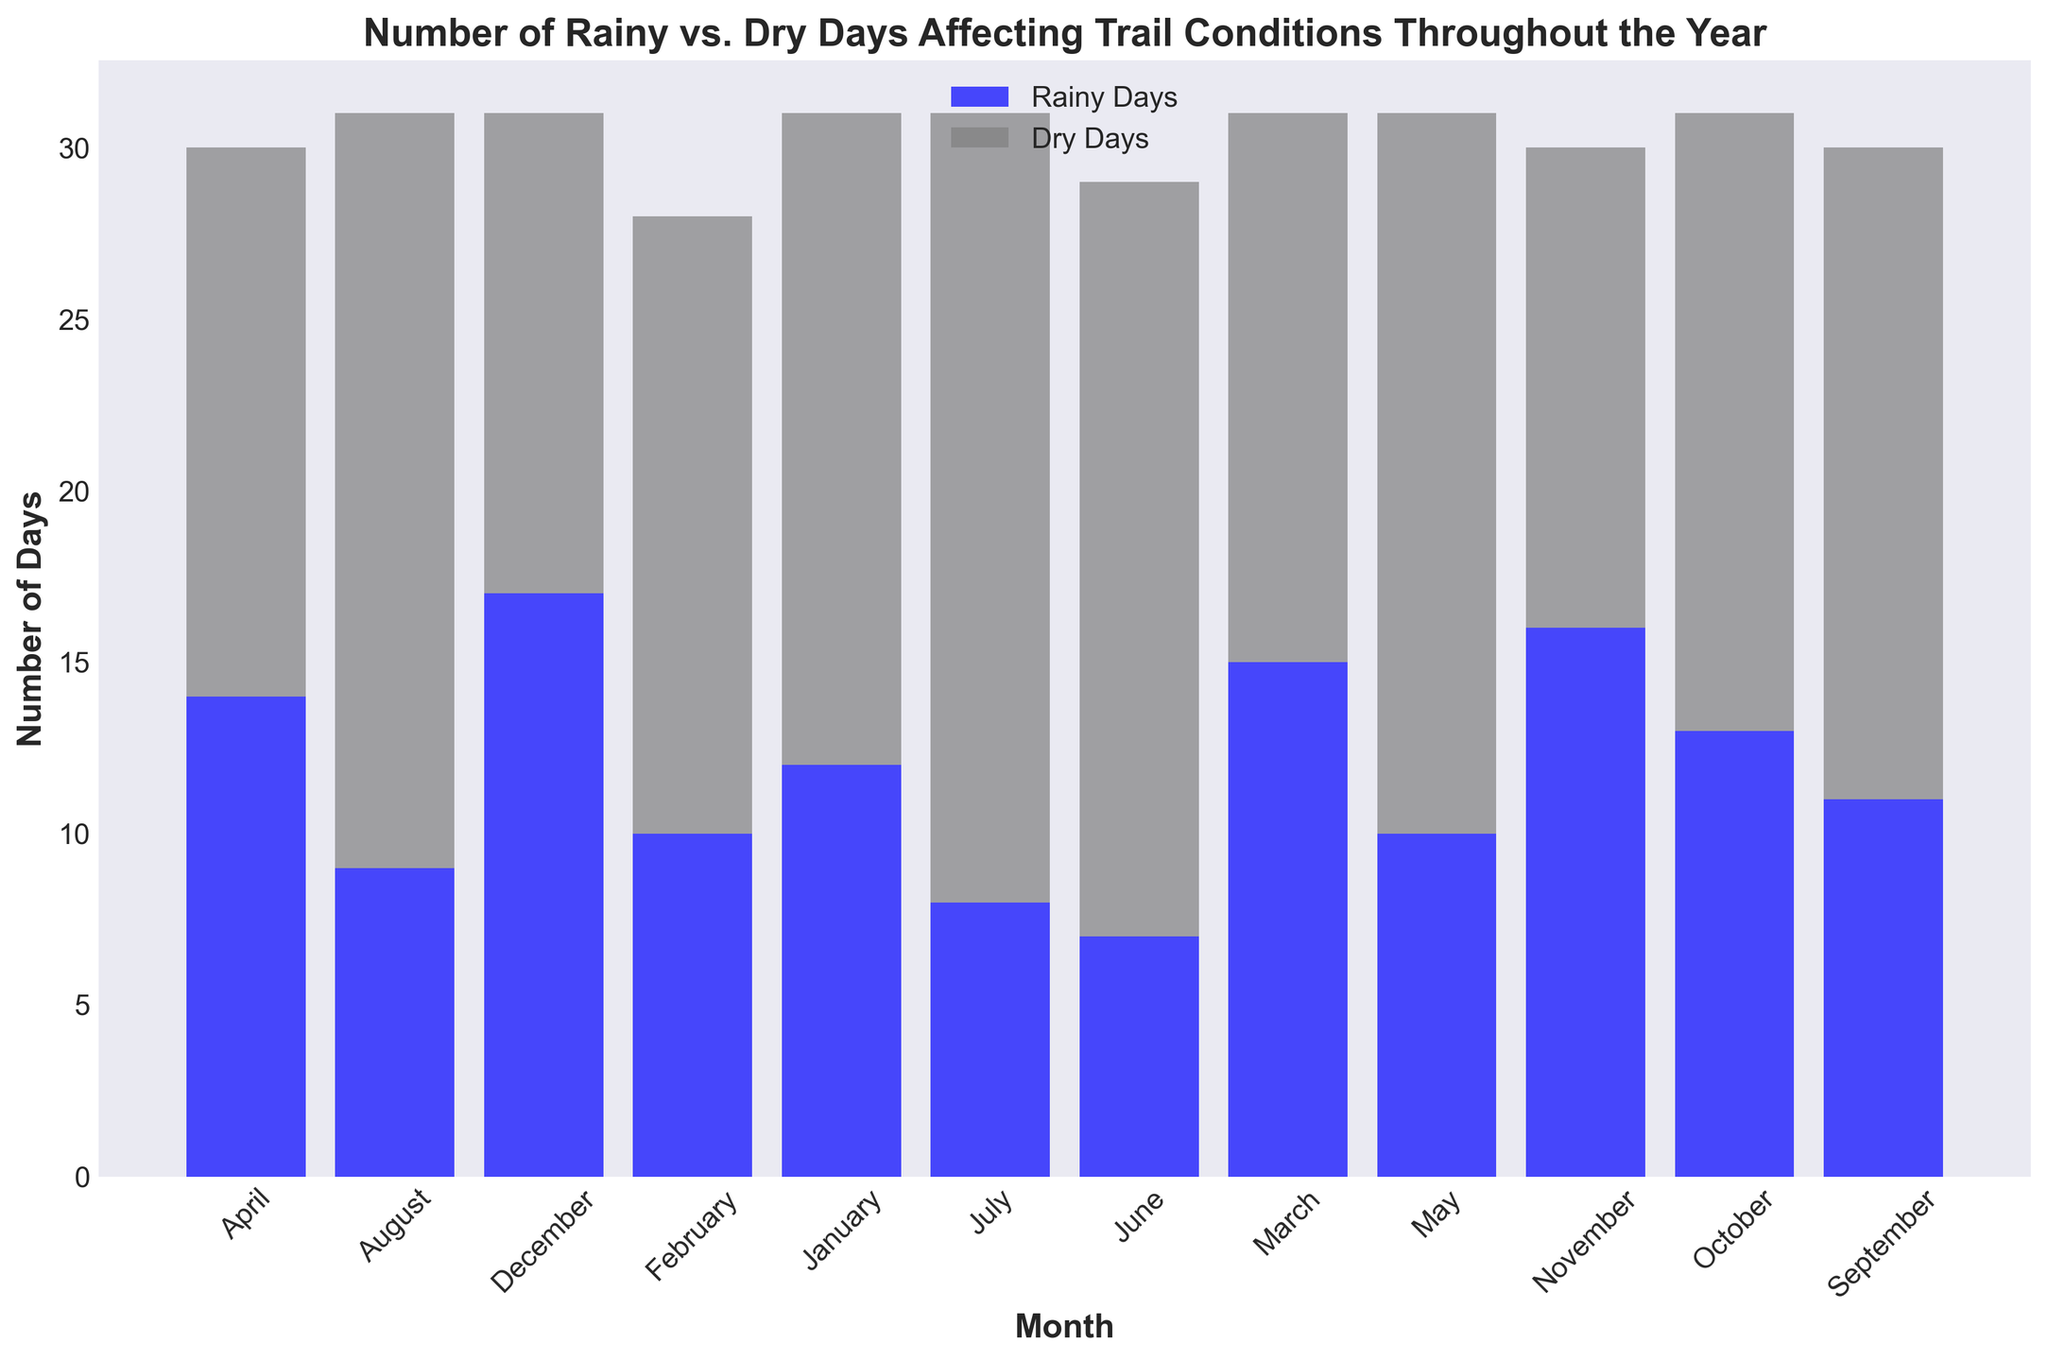Which month has the highest number of combined rainy and dry days? To determine the month with the highest number of combined rainy and dry days, sum up the rainy and dry days for each month, and then compare the total values. July has 8 rainy days and 23 dry days, making a total of 31 days, which is the highest.
Answer: July How many more rainy days are there in December compared to June? Subtract the number of rainy days in June from the number of rainy days in December. December has 17 rainy days and June has 7, so the difference is 17 - 7 = 10.
Answer: 10 Are there any months where the number of rainy days is equal to or exceeds the number of dry days? Compare the number of rainy days to the number of dry days for each month. November and December are the months where the rainy days either equal or exceed the dry days.
Answer: November and December What is the average number of dry days over the entire year? Sum the number of dry days for each month and divide by the number of months (12). The total number of dry days is 19 + 18 + 16 + 16 + 21 + 22 + 23 + 22 + 19 + 18 + 14 + 14 = 222. The average is 222 / 12 = 18.5.
Answer: 18.5 Which month has the fewest dry days? Simply inspect the plot to find the month with the shortest gray bar. June and December each have the shortest gray bars representing 14 dry days.
Answer: June and December What is the difference in the number of dry days between January and May? Subtract the number of dry days in January from those in May. May has 21 dry days and January has 19, so the difference is 21 - 19 = 2.
Answer: 2 Is the number of rainy days in April greater than the number of rainy days in February? Inspect the height of the blue bars for April and February. April has 14 rainy days, while February has 10. Thus, 14 > 10.
Answer: Yes Which month shows the greatest difference between the number of rainy and dry days? Calculate the difference between rainy and dry days for each month and identify the maximum difference. July has 23 dry days and 8 rainy days, so the difference is 23 - 8 = 15, the greatest observed.
Answer: July 